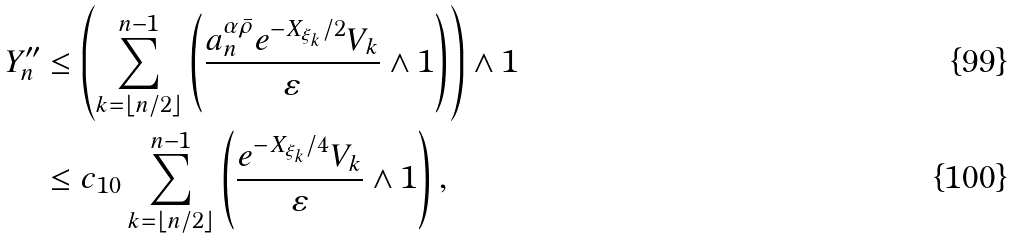Convert formula to latex. <formula><loc_0><loc_0><loc_500><loc_500>Y _ { n } ^ { \prime \prime } & \leq \left ( \sum _ { k = \lfloor n / 2 \rfloor } ^ { n - 1 } \left ( \frac { a _ { n } ^ { \alpha \bar { \rho } } e ^ { - X _ { \xi _ { k } } / 2 } V _ { k } } { \varepsilon } \wedge 1 \right ) \right ) \wedge 1 \\ & \leq c _ { 1 0 } \sum _ { k = \lfloor n / 2 \rfloor } ^ { n - 1 } \left ( \frac { e ^ { - X _ { \xi _ { k } } / 4 } V _ { k } } { \varepsilon } \wedge 1 \right ) ,</formula> 